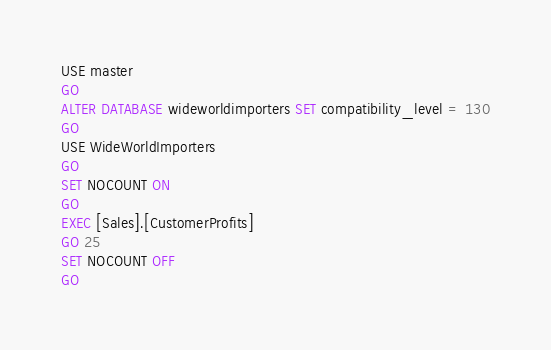<code> <loc_0><loc_0><loc_500><loc_500><_SQL_>USE master
GO
ALTER DATABASE wideworldimporters SET compatibility_level = 130
GO
USE WideWorldImporters
GO
SET NOCOUNT ON
GO
EXEC [Sales].[CustomerProfits]
GO 25
SET NOCOUNT OFF
GO</code> 